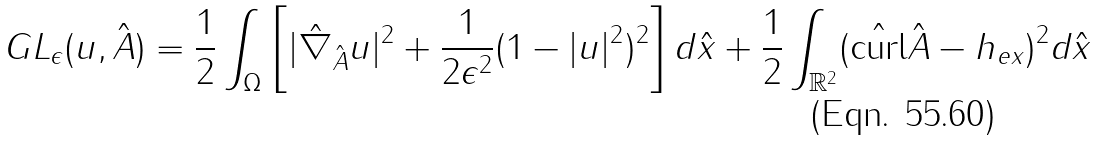Convert formula to latex. <formula><loc_0><loc_0><loc_500><loc_500>G L _ { \epsilon } ( u , \hat { A } ) = \frac { 1 } { 2 } \int _ { \Omega } \left [ | \hat { \nabla } _ { \hat { A } } u | ^ { 2 } + \frac { 1 } { 2 \epsilon ^ { 2 } } ( 1 - | u | ^ { 2 } ) ^ { 2 } \right ] d \hat { x } + \frac { 1 } { 2 } \int _ { \mathbb { R } ^ { 2 } } ( \hat { \text {curl} } \hat { A } - h _ { e x } ) ^ { 2 } d \hat { x }</formula> 